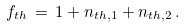<formula> <loc_0><loc_0><loc_500><loc_500>f _ { t h } \, = \, 1 + n _ { t h , 1 } + n _ { t h , 2 } \, .</formula> 